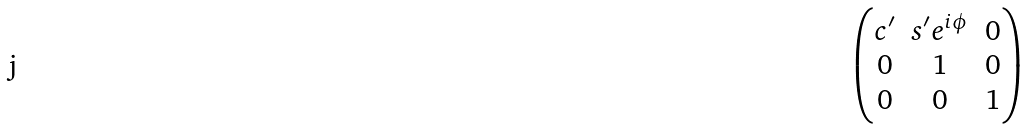<formula> <loc_0><loc_0><loc_500><loc_500>\begin{pmatrix} c ^ { \prime } & s ^ { \prime } e ^ { i \phi } & 0 \\ 0 & 1 & 0 \\ 0 & 0 & 1 \end{pmatrix}</formula> 